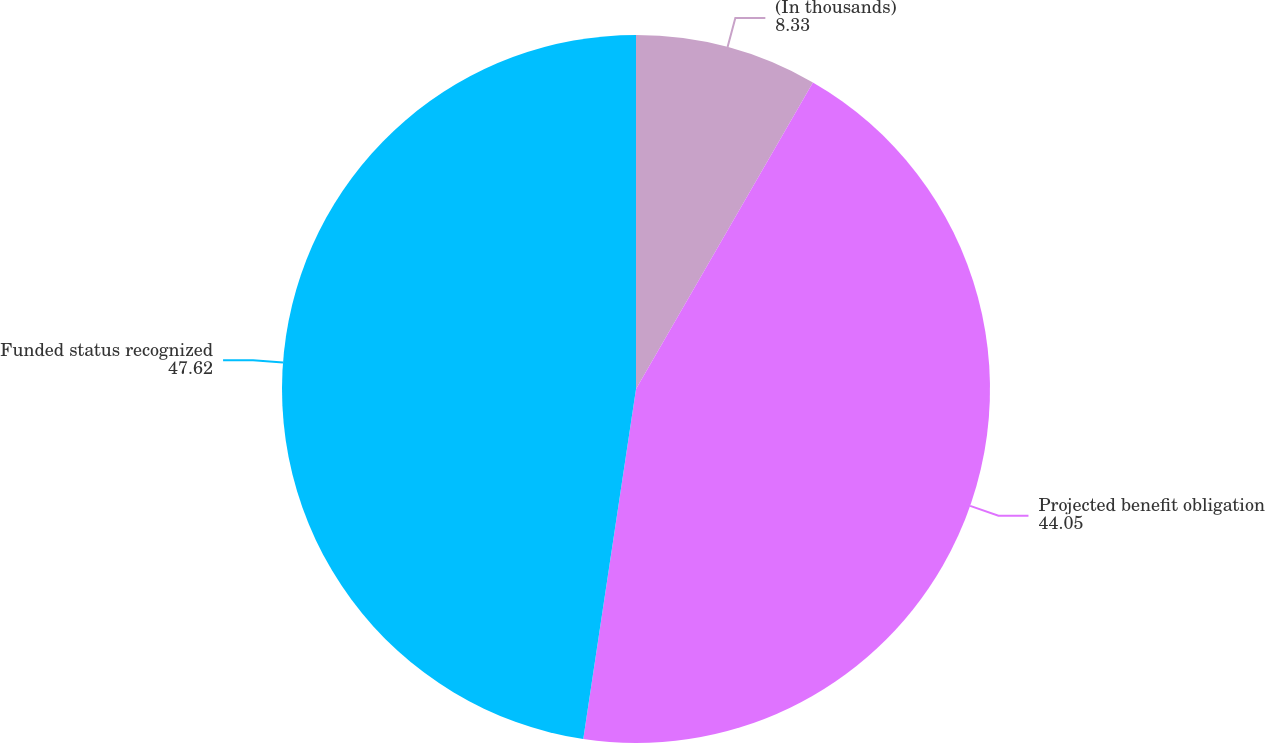Convert chart. <chart><loc_0><loc_0><loc_500><loc_500><pie_chart><fcel>(In thousands)<fcel>Projected benefit obligation<fcel>Funded status recognized<nl><fcel>8.33%<fcel>44.05%<fcel>47.62%<nl></chart> 